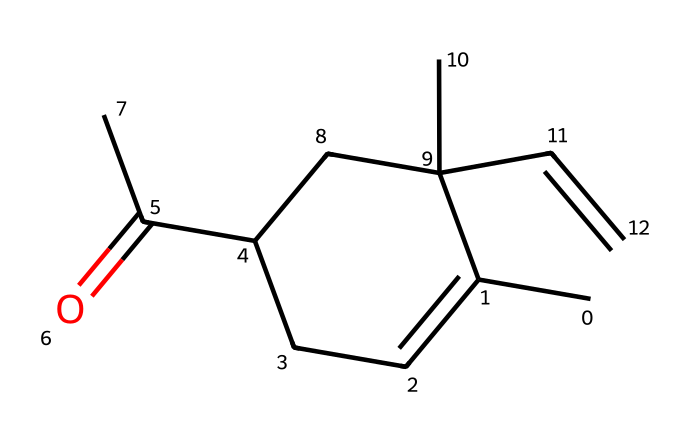How many chiral centers are present in the carvone molecule? The structure shows that there are two carbon atoms bonded to four different substituents. These are the criteria for a carbon atom to be a chiral center. Counting these, we find there are two such carbon atoms in the carvone structure.
Answer: two What is the functional group present in carvone? By analyzing the structure, the presence of a carbonyl group (C=O) indicates that carvone contains a ketone functional group. This is defined by the carbon atom being double-bonded to an oxygen atom within the carbon chain.
Answer: ketone What type of isomerism is exhibited by carvone? Since carvone has chiral centers, it displays optical isomerism. This results in the existence of two enantiomers that are non-superimposable mirror images of each other.
Answer: optical What is the molecular formula of carvone? By counting all carbon, hydrogen, and oxygen atoms in the structure, we find the molecular formula to be C10H14O. This includes 10 carbons, 14 hydrogens, and 1 oxygen atom.
Answer: C10H14O Which compound is indicated as the source of the spearmint aroma? The specific isomer of carvone responsible for the spearmint aroma is (R)-carvone. This particular configuration around the chiral center influences the olfactory properties of the compound.
Answer: (R)-carvone 